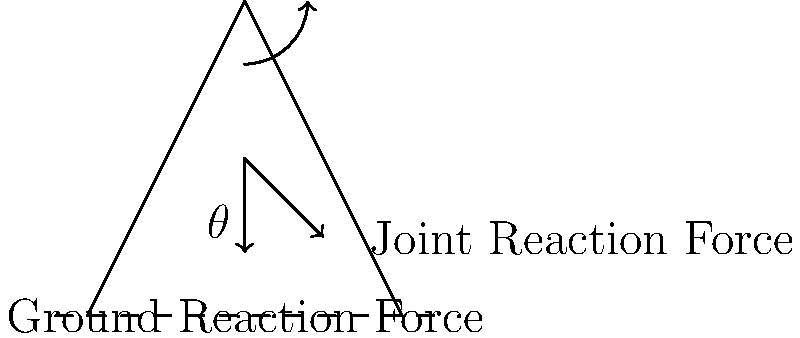As a physical therapist, you're analyzing the forces acting on the knee joint during a squat. The diagram shows a simplified representation of the leg during a squat, with $\theta$ representing the knee flexion angle. How does the joint reaction force (JRF) at the knee change as the squat depth increases (i.e., as $\theta$ increases)? Consider the health implications of your answer. To understand how the joint reaction force (JRF) changes as squat depth increases, let's break it down step-by-step:

1. Force analysis:
   - The primary forces acting on the knee are the ground reaction force (GRF) and the joint reaction force (JRF).
   - The GRF is relatively constant during a squat, assuming constant body weight.

2. Moment arm changes:
   - As squat depth increases ($\theta$ increases), the moment arm of the GRF about the knee joint increases.
   - This increased moment arm results in a greater torque at the knee.

3. Muscle force requirement:
   - To counteract the increased torque, the quadriceps muscles must generate more force.
   - The increased muscle force contributes to a higher JRF.

4. Vector components:
   - The JRF can be resolved into compressive and shear components.
   - As $\theta$ increases, both components generally increase, but the shear component increases at a faster rate.

5. Patellofemoral contact area:
   - With increased knee flexion, the contact area between the patella and femur increases.
   - This helps distribute the increased force over a larger area, potentially reducing stress.

6. Overall JRF magnitude:
   - The magnitude of the JRF increases as squat depth increases, due to the combined effects of increased muscle force and altered joint geometry.

Health implications:
- Increased JRF can lead to greater stress on articular cartilage and other knee structures.
- However, the increased patellofemoral contact area may help mitigate some of this stress.
- Proper technique and gradual progression are crucial to allow tissues to adapt to these increased forces.
- For individuals with knee pathologies, limiting squat depth may be advisable to manage JRF magnitude.
Answer: JRF increases with squat depth due to increased muscle force and altered joint geometry. 